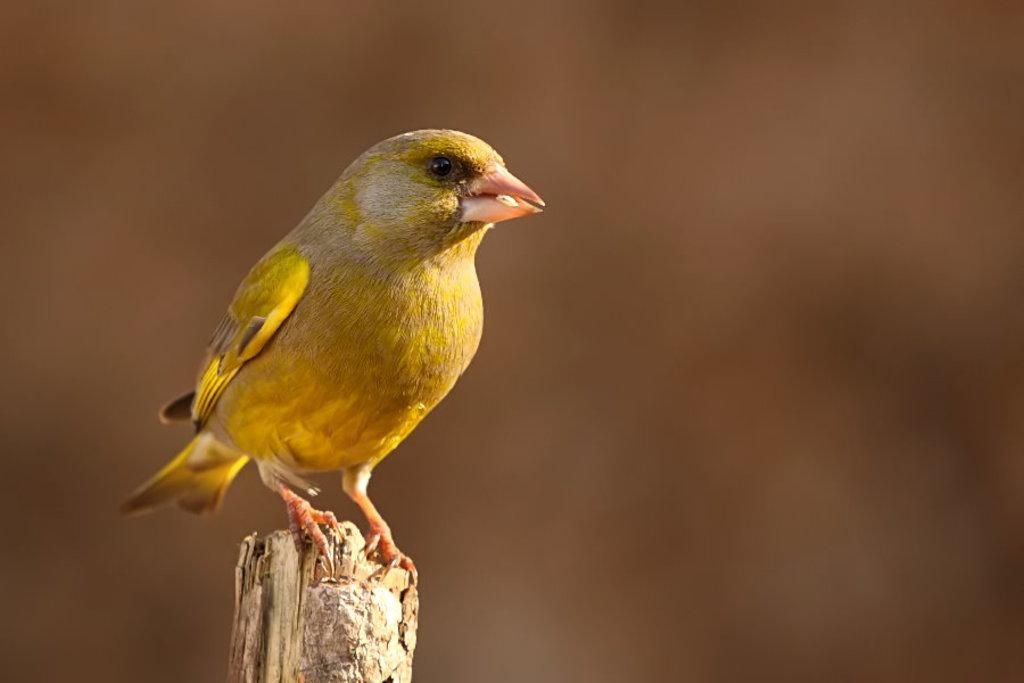What type of animal is in the image? There is a bird in the image. What is the bird perched on? The bird is on a wooden stick. Can you describe the background of the image? The background of the image is blurry. How many ants can be seen crawling on the bird in the image? There are no ants present in the image; it features a bird on a wooden stick with a blurry background. 